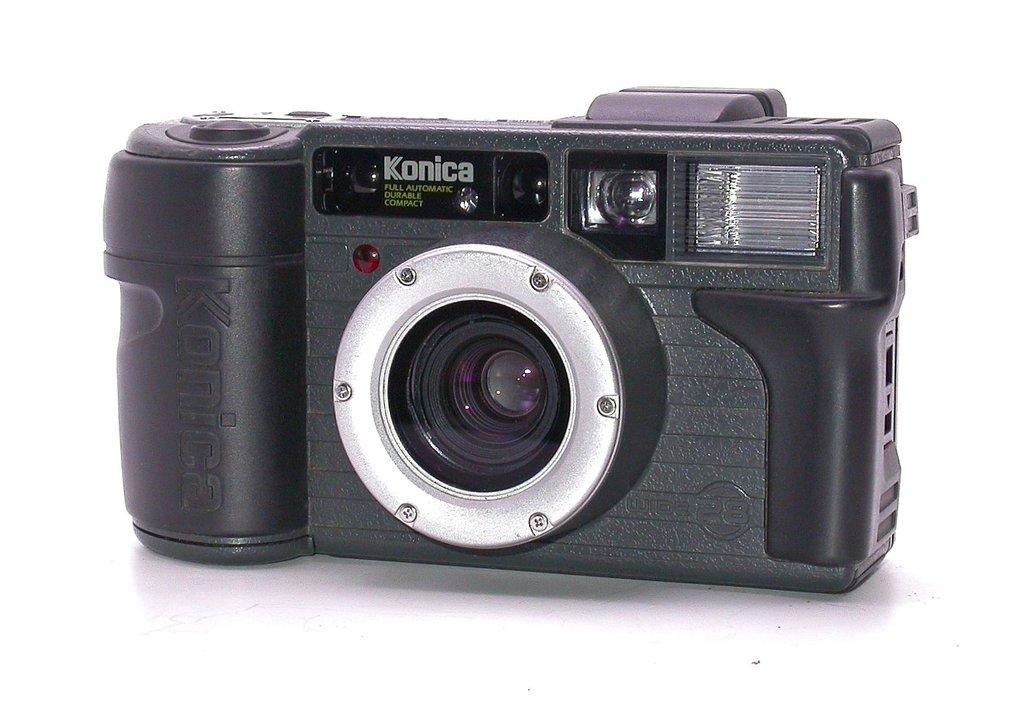What object is the main subject of the image? There is a camera in the image. Where is the camera located in the image? The camera is placed on a surface. What type of silk fabric is draped over the camera in the image? There is no silk fabric present in the image; it only features a camera placed on a surface. 